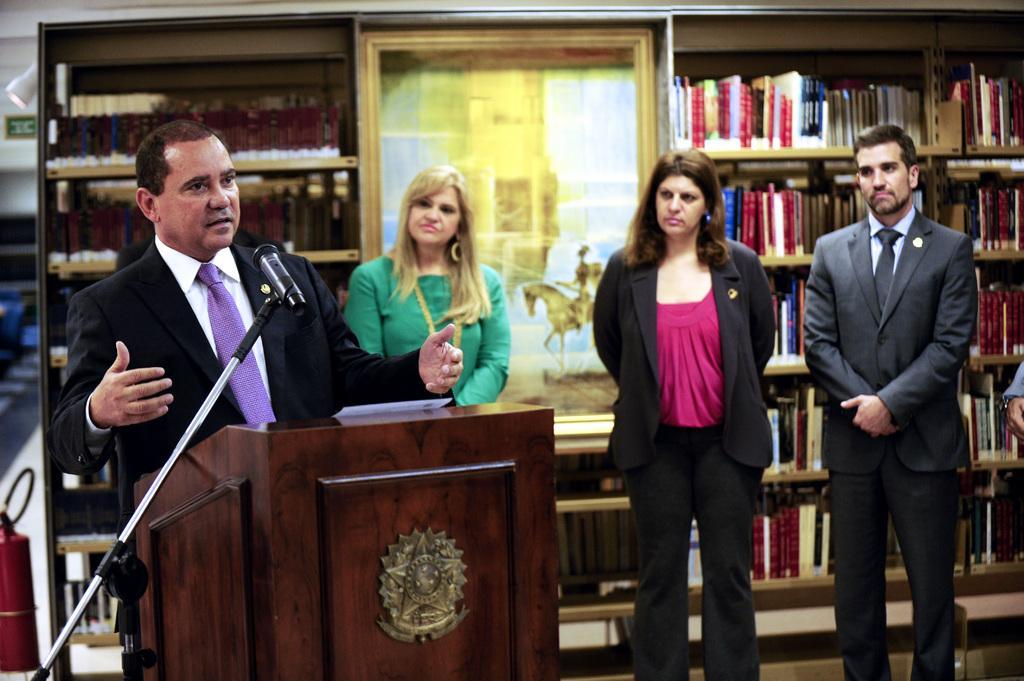In one or two sentences, can you explain what this image depicts? 4 people are standing in a room. A person is standing at the left wearing a suit and there is a microphone, stand and paper. There are book shelves at the back and there is a fire hydrant at the left. 